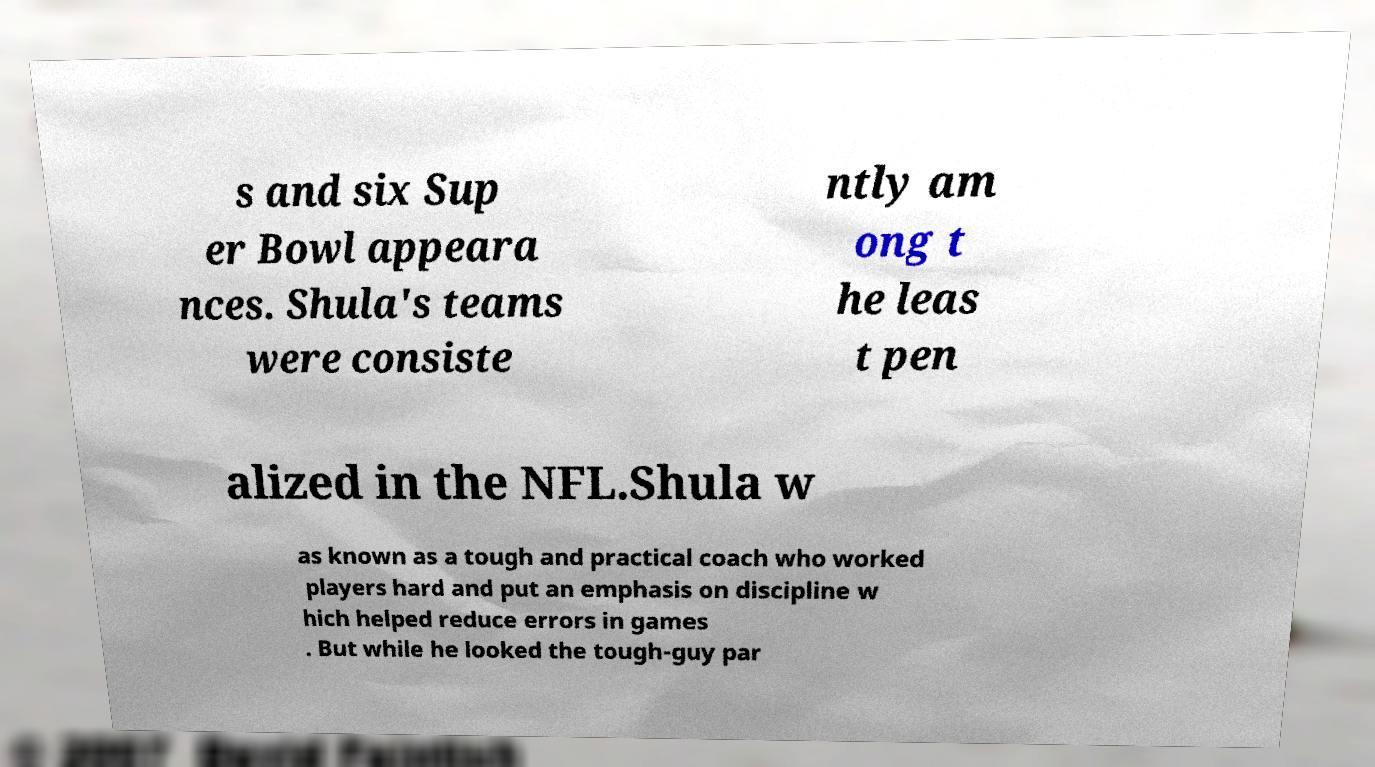Can you accurately transcribe the text from the provided image for me? s and six Sup er Bowl appeara nces. Shula's teams were consiste ntly am ong t he leas t pen alized in the NFL.Shula w as known as a tough and practical coach who worked players hard and put an emphasis on discipline w hich helped reduce errors in games . But while he looked the tough-guy par 